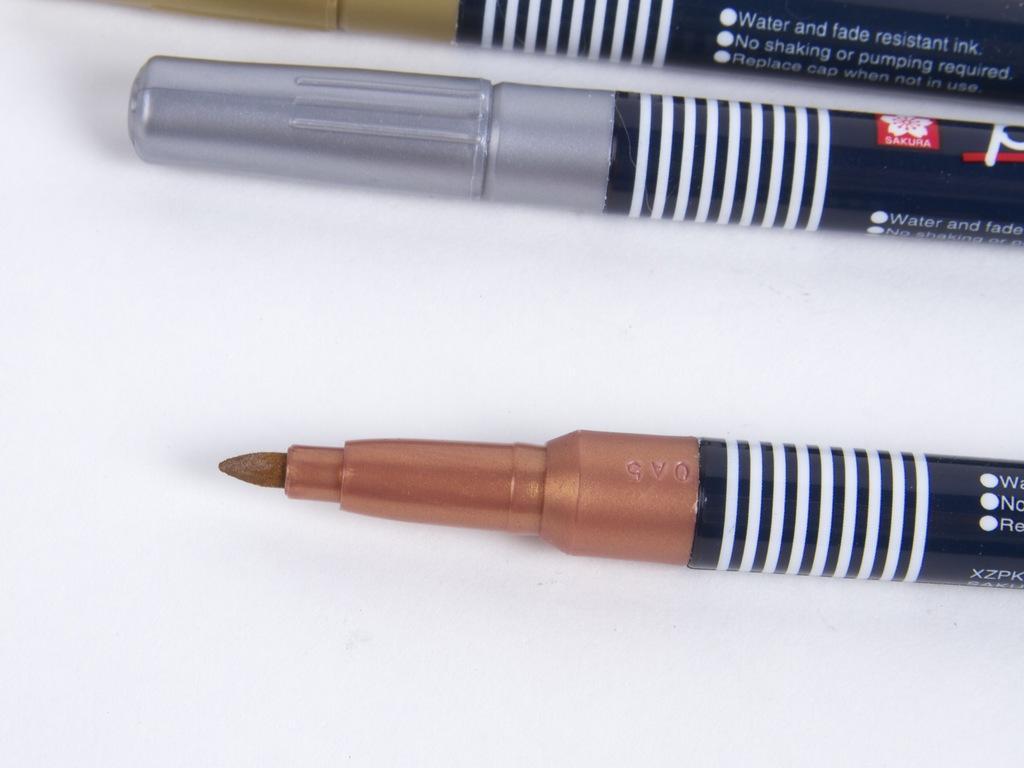Describe this image in one or two sentences. In this picture we can see marker pens. 